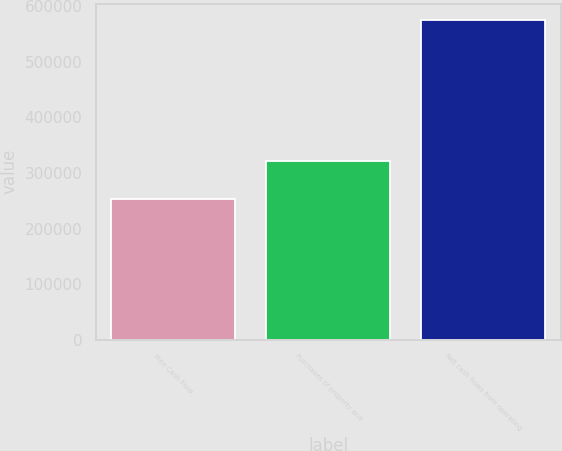Convert chart. <chart><loc_0><loc_0><loc_500><loc_500><bar_chart><fcel>Free Cash Flow<fcel>Purchases of property and<fcel>Net cash flows from operating<nl><fcel>253762<fcel>321819<fcel>575581<nl></chart> 